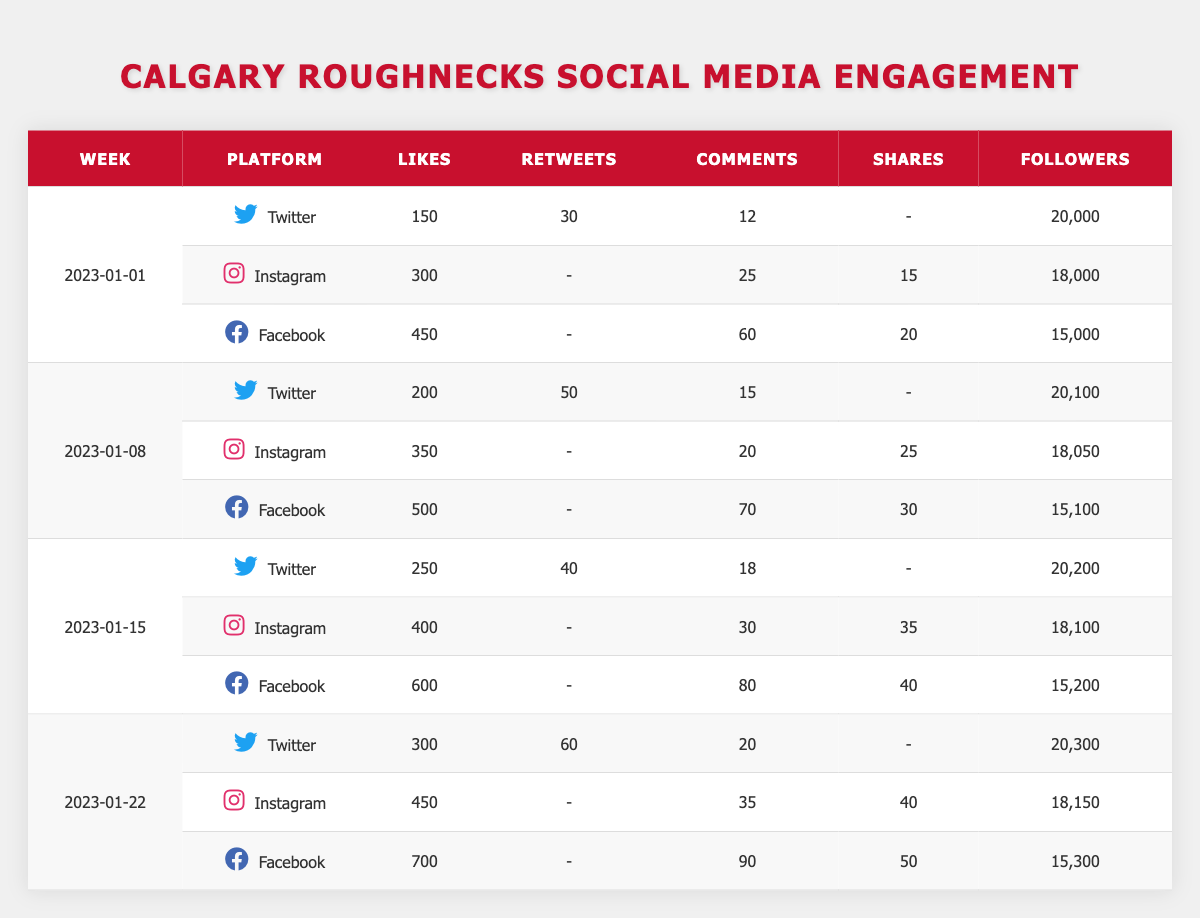What was the total number of likes received on Facebook during the week of 2023-01-08? According to the table, the likes on Facebook for that week were 500. Therefore, the total number of likes is 500.
Answer: 500 Which social media platform had the highest number of comments on 2023-01-15? On 2023-01-15, Facebook had 80 comments, Twitter had 18 comments, and Instagram had 30 comments. The highest number is from Facebook with 80 comments.
Answer: Facebook Did the followers on Twitter increase or decrease from the week of 2023-01-01 to 2023-01-22? The followers on Twitter increased from 20,000 on 2023-01-01 to 20,300 on 2023-01-22. Therefore, there was an increase.
Answer: Increase What were the average number of likes across all platforms for the week of 2023-01-08? The likes for that week were: Twitter (200), Instagram (350), and Facebook (500). The total likes are 200 + 350 + 500 = 1050, and there are 3 platforms. The average is 1050 / 3 = 350.
Answer: 350 How many shares were recorded on Instagram during the week of 2023-01-22? For Instagram on 2023-01-22, the shares recorded were 40.
Answer: 40 What is the difference in the number of followers from the week of 2023-01-01 to 2023-01-15 on Instagram? Followers for Instagram on 2023-01-01 were 18,000 and on 2023-01-15 they were 18,100. The difference is 18,100 - 18,000 = 100.
Answer: 100 Which week saw the highest number of retweets on Twitter? The retweets for Twitter were 30 on 2023-01-01, 50 on 2023-01-08, 40 on 2023-01-15, and 60 on 2023-01-22. The highest is 60 retweets on 2023-01-22.
Answer: 2023-01-22 Is it true that Instagram had more likes than Twitter in the week of 2023-01-22? The likes on that week were: Instagram (450) and Twitter (300). Since 450 is greater than 300, it is true that Instagram had more likes than Twitter.
Answer: True What was the total engagement (likes, comments, and shares) for Facebook on the week of 2023-01-01? The total engagement for Facebook is calculated as likes (450) + comments (60) + shares (20) = 450 + 60 + 20 = 530.
Answer: 530 In which week did the Calgary Roughnecks gain the most followers on their Twitter account? The followers on Twitter were: 20,000 on 2023-01-01, 20,100 on 2023-01-08, 20,200 on 2023-01-15, and 20,300 on 2023-01-22. The most gained is 20,300 followers on 2023-01-22.
Answer: 2023-01-22 